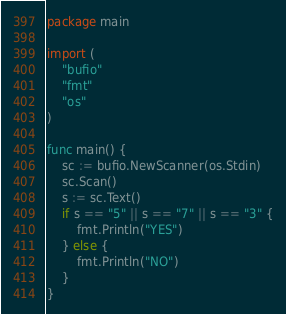<code> <loc_0><loc_0><loc_500><loc_500><_Go_>package main

import (
	"bufio"
	"fmt"
	"os"
)

func main() {
	sc := bufio.NewScanner(os.Stdin)
	sc.Scan()
	s := sc.Text()
	if s == "5" || s == "7" || s == "3" {
		fmt.Println("YES")
	} else {
		fmt.Println("NO")
	}
}
</code> 